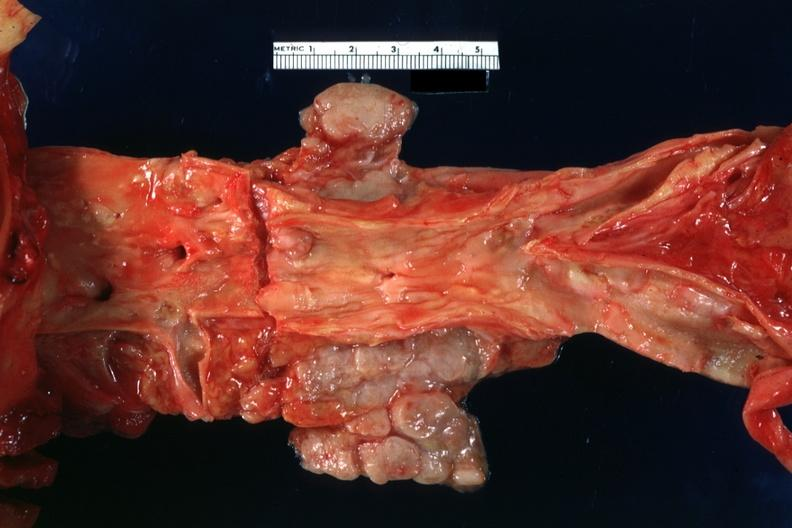s lymph node present?
Answer the question using a single word or phrase. Yes 